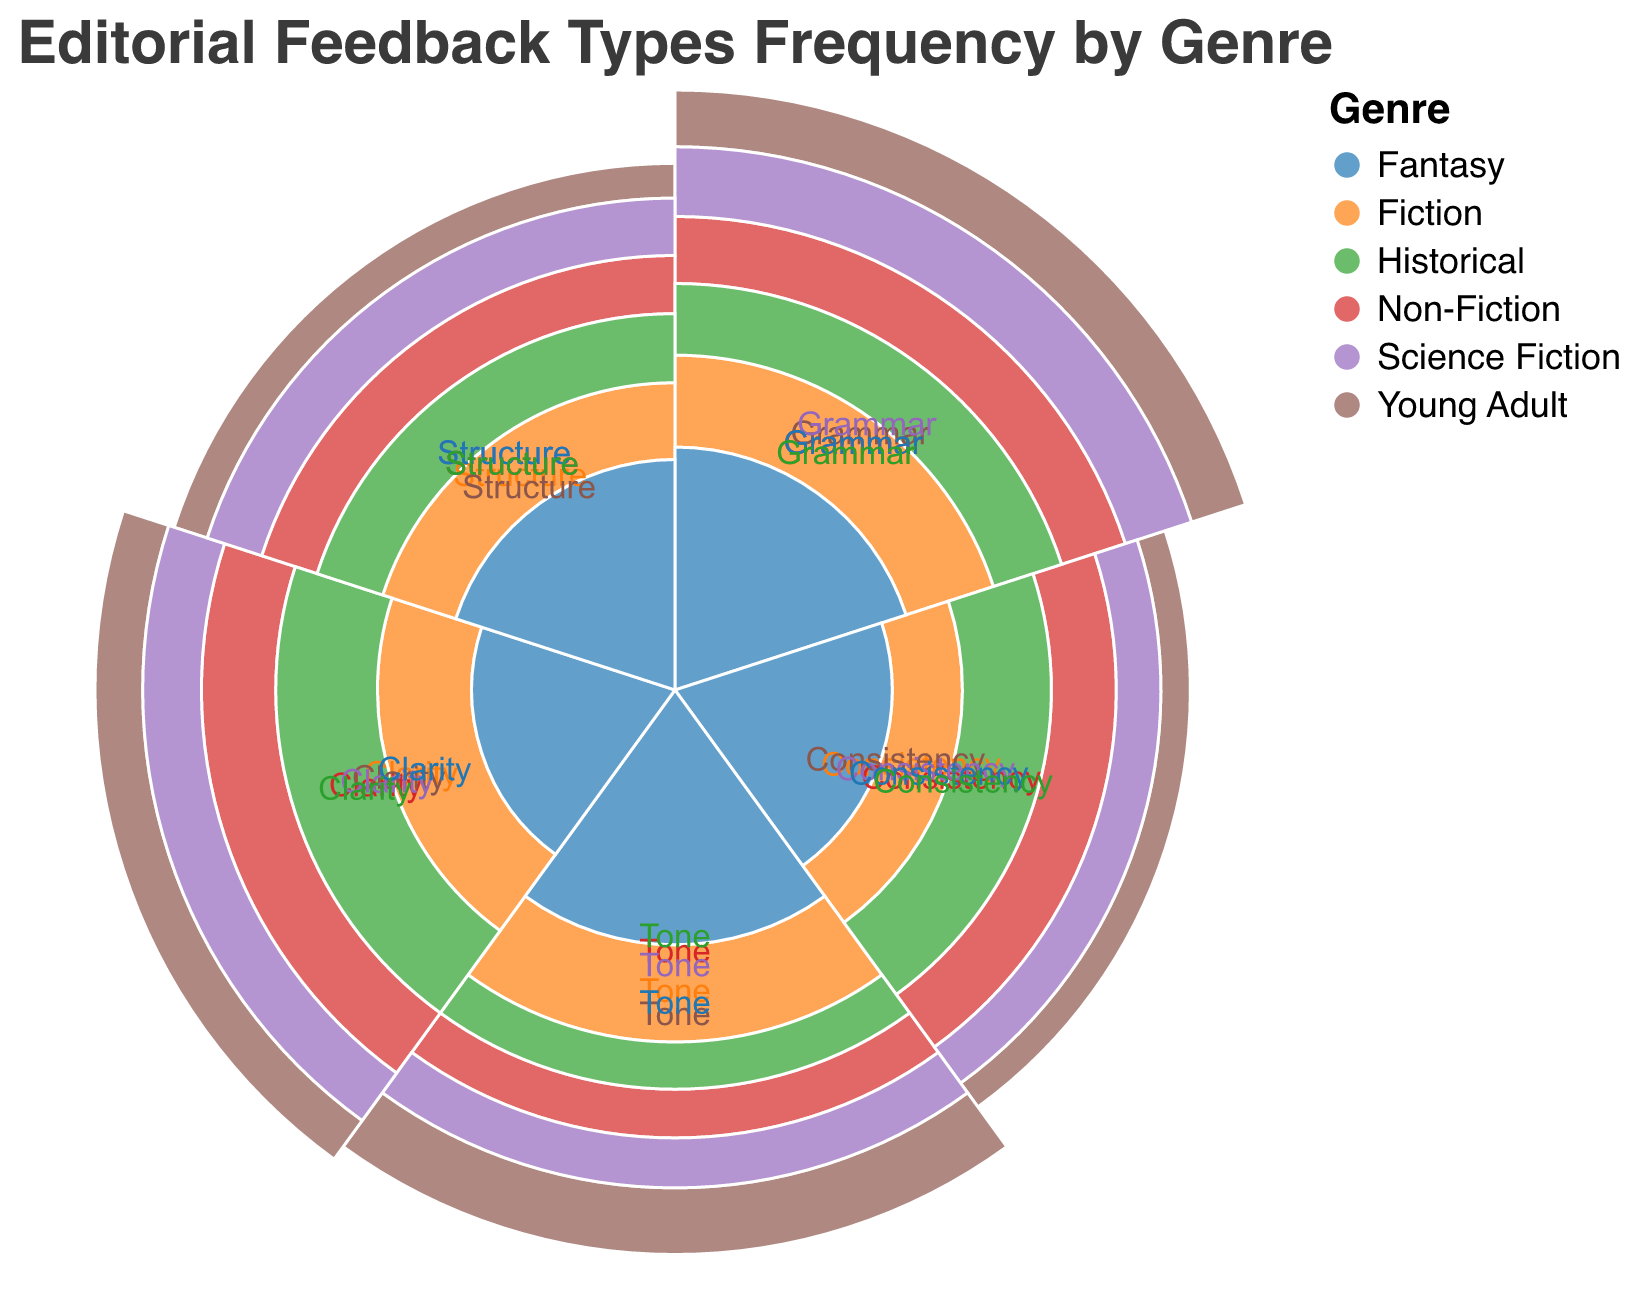What is the most frequent type of feedback for Young Adult genre? The type of feedback with the highest value for Young Adult genre is "Tone" with a frequency value of 60.
Answer: Tone Which genre has the highest frequency of Grammar feedback? By comparing the Grammar values for each genre, Science Fiction has the highest frequency with a value of 60.
Answer: Science Fiction What is the difference between the Structure feedback frequencies for Fiction and Fantasy genres? The Structure feedback frequency for Fiction is 35, and for Fantasy, it is 45. The difference is 45 - 35 = 10.
Answer: 10 Which feedback type has the least frequency in the Non-Fiction genre? In the Non-Fiction genre, the "Tone" feedback type has the least frequency with a value of 35.
Answer: Tone How does the Consistency feedback frequency for Historical genre compare to its Clarity feedback frequency? The Consistency feedback frequency for Historical genre is 50, while the Clarity feedback frequency is 60. Thus, Clarity is greater by 10.
Answer: Clarity is greater by 10 What is the average frequency of Tone feedback across all genres? Add the Tone feedback values for each genre (50 + 35 + 60 + 40 + 55 + 30 = 270) and divide by the number of genres (6). The average is 270 / 6 = 45.
Answer: 45 In which genres is the Clarity feedback frequency greater than 50? In Non-Fiction (55), Science Fiction (50), and Historical (60), the Clarity feedback frequency is greater than 50.
Answer: Non-Fiction, Historical What is the total combined frequency of Grammar feedback for Fiction, Non-Fiction, and Young Adult genres? Add the Grammar feedback values for Fiction (45), Non-Fiction (50), and Young Adult (55). The total combined frequency is 45 + 50 + 55 = 150.
Answer: 150 What is the ratio of Consistency feedback in Fantasy to Fiction genres? The Consistency feedback in Fantasy is 40, and in Fiction, it is 30. The ratio is 40/30, which simplifies to 4:3.
Answer: 4:3 Which genre has the most balanced feedback across all types? By visually examining the distribution of feedback frequencies, Non-Fiction has more balanced values across Grammar (50), Consistency (45), Tone (35), Clarity (55), and Structure (40).
Answer: Non-Fiction 